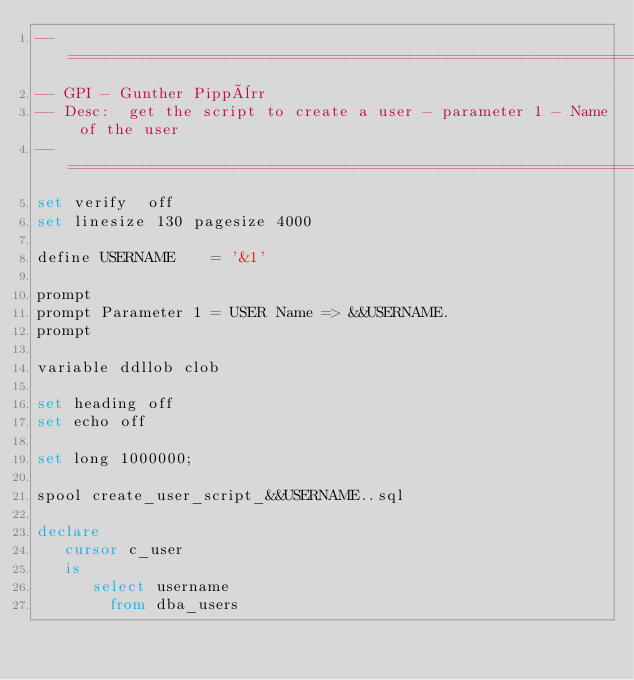<code> <loc_0><loc_0><loc_500><loc_500><_SQL_>--==============================================================================
-- GPI - Gunther Pippèrr
-- Desc:  get the script to create a user - parameter 1 - Name of the user
--==============================================================================
set verify  off
set linesize 130 pagesize 4000 

define USERNAME    = '&1'

prompt
prompt Parameter 1 = USER Name => &&USERNAME.
prompt

variable ddllob clob

set heading off
set echo off

set long 1000000;

spool create_user_script_&&USERNAME..sql

declare
   cursor c_user
   is
      select username
        from dba_users</code> 